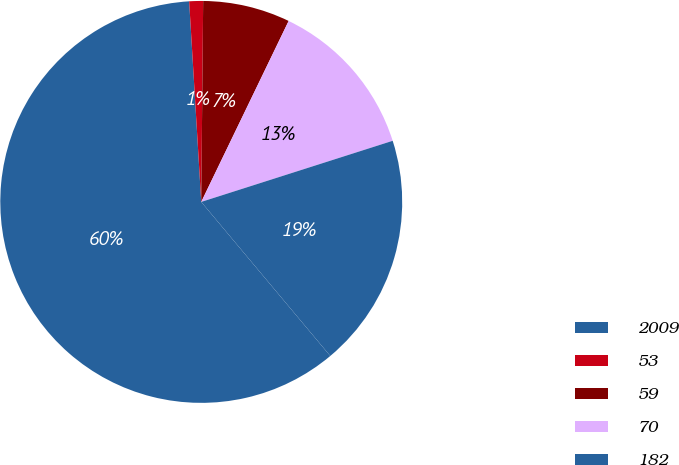Convert chart. <chart><loc_0><loc_0><loc_500><loc_500><pie_chart><fcel>2009<fcel>53<fcel>59<fcel>70<fcel>182<nl><fcel>60.14%<fcel>1.11%<fcel>7.01%<fcel>12.92%<fcel>18.82%<nl></chart> 